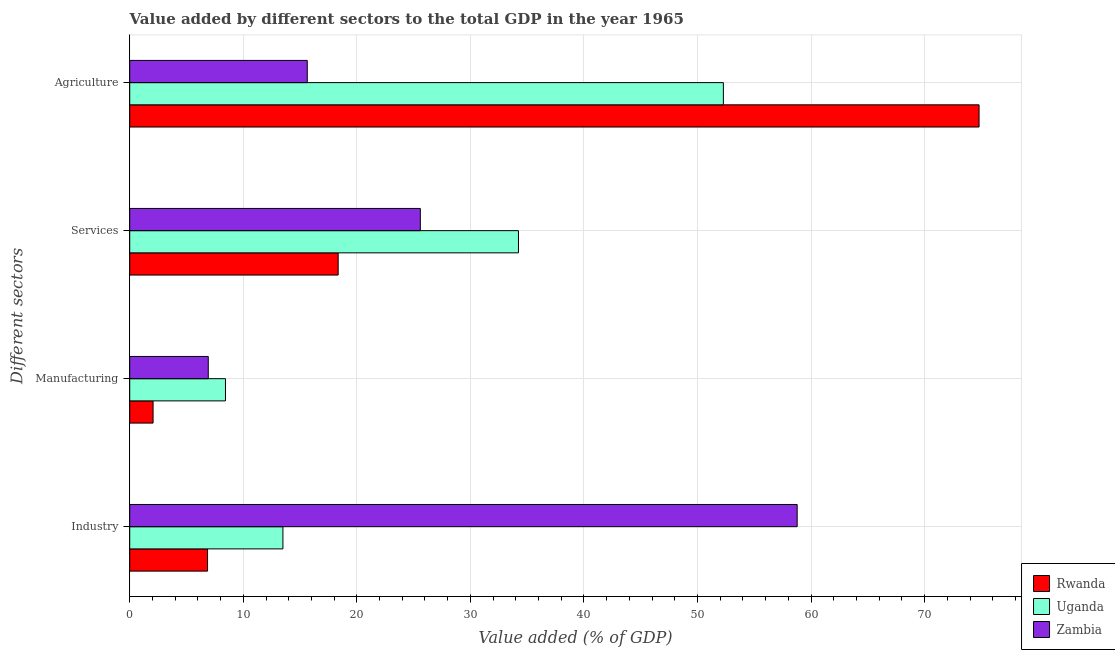How many different coloured bars are there?
Your answer should be compact. 3. How many groups of bars are there?
Give a very brief answer. 4. Are the number of bars per tick equal to the number of legend labels?
Your answer should be compact. Yes. How many bars are there on the 4th tick from the bottom?
Ensure brevity in your answer.  3. What is the label of the 2nd group of bars from the top?
Your answer should be compact. Services. What is the value added by agricultural sector in Uganda?
Make the answer very short. 52.28. Across all countries, what is the maximum value added by services sector?
Keep it short and to the point. 34.23. Across all countries, what is the minimum value added by manufacturing sector?
Your answer should be compact. 2.06. In which country was the value added by services sector maximum?
Your answer should be compact. Uganda. In which country was the value added by industrial sector minimum?
Your response must be concise. Rwanda. What is the total value added by agricultural sector in the graph?
Offer a very short reply. 142.7. What is the difference between the value added by industrial sector in Zambia and that in Rwanda?
Offer a very short reply. 51.92. What is the difference between the value added by services sector in Uganda and the value added by manufacturing sector in Rwanda?
Your response must be concise. 32.18. What is the average value added by agricultural sector per country?
Your answer should be very brief. 47.57. What is the difference between the value added by manufacturing sector and value added by services sector in Rwanda?
Give a very brief answer. -16.3. What is the ratio of the value added by services sector in Rwanda to that in Uganda?
Offer a very short reply. 0.54. Is the value added by agricultural sector in Uganda less than that in Zambia?
Your response must be concise. No. Is the difference between the value added by industrial sector in Zambia and Rwanda greater than the difference between the value added by manufacturing sector in Zambia and Rwanda?
Provide a short and direct response. Yes. What is the difference between the highest and the second highest value added by agricultural sector?
Your answer should be very brief. 22.52. What is the difference between the highest and the lowest value added by agricultural sector?
Provide a succinct answer. 59.16. What does the 3rd bar from the top in Services represents?
Give a very brief answer. Rwanda. What does the 3rd bar from the bottom in Manufacturing represents?
Offer a terse response. Zambia. What is the difference between two consecutive major ticks on the X-axis?
Your answer should be compact. 10. Does the graph contain any zero values?
Provide a succinct answer. No. How many legend labels are there?
Offer a terse response. 3. How are the legend labels stacked?
Your answer should be compact. Vertical. What is the title of the graph?
Your answer should be compact. Value added by different sectors to the total GDP in the year 1965. What is the label or title of the X-axis?
Ensure brevity in your answer.  Value added (% of GDP). What is the label or title of the Y-axis?
Ensure brevity in your answer.  Different sectors. What is the Value added (% of GDP) in Rwanda in Industry?
Your answer should be compact. 6.85. What is the Value added (% of GDP) of Uganda in Industry?
Offer a terse response. 13.49. What is the Value added (% of GDP) in Zambia in Industry?
Offer a terse response. 58.78. What is the Value added (% of GDP) in Rwanda in Manufacturing?
Offer a terse response. 2.06. What is the Value added (% of GDP) in Uganda in Manufacturing?
Your answer should be compact. 8.43. What is the Value added (% of GDP) of Zambia in Manufacturing?
Your answer should be compact. 6.92. What is the Value added (% of GDP) of Rwanda in Services?
Provide a short and direct response. 18.35. What is the Value added (% of GDP) in Uganda in Services?
Provide a short and direct response. 34.23. What is the Value added (% of GDP) of Zambia in Services?
Offer a terse response. 25.59. What is the Value added (% of GDP) in Rwanda in Agriculture?
Make the answer very short. 74.79. What is the Value added (% of GDP) of Uganda in Agriculture?
Make the answer very short. 52.28. What is the Value added (% of GDP) in Zambia in Agriculture?
Keep it short and to the point. 15.63. Across all Different sectors, what is the maximum Value added (% of GDP) in Rwanda?
Your response must be concise. 74.79. Across all Different sectors, what is the maximum Value added (% of GDP) of Uganda?
Give a very brief answer. 52.28. Across all Different sectors, what is the maximum Value added (% of GDP) of Zambia?
Your answer should be compact. 58.78. Across all Different sectors, what is the minimum Value added (% of GDP) of Rwanda?
Provide a succinct answer. 2.06. Across all Different sectors, what is the minimum Value added (% of GDP) in Uganda?
Ensure brevity in your answer.  8.43. Across all Different sectors, what is the minimum Value added (% of GDP) of Zambia?
Ensure brevity in your answer.  6.92. What is the total Value added (% of GDP) of Rwanda in the graph?
Your answer should be very brief. 102.06. What is the total Value added (% of GDP) of Uganda in the graph?
Ensure brevity in your answer.  108.43. What is the total Value added (% of GDP) in Zambia in the graph?
Offer a very short reply. 106.92. What is the difference between the Value added (% of GDP) of Rwanda in Industry and that in Manufacturing?
Your response must be concise. 4.8. What is the difference between the Value added (% of GDP) of Uganda in Industry and that in Manufacturing?
Your answer should be very brief. 5.06. What is the difference between the Value added (% of GDP) of Zambia in Industry and that in Manufacturing?
Your answer should be very brief. 51.86. What is the difference between the Value added (% of GDP) in Rwanda in Industry and that in Services?
Give a very brief answer. -11.5. What is the difference between the Value added (% of GDP) of Uganda in Industry and that in Services?
Your answer should be compact. -20.74. What is the difference between the Value added (% of GDP) in Zambia in Industry and that in Services?
Provide a short and direct response. 33.18. What is the difference between the Value added (% of GDP) in Rwanda in Industry and that in Agriculture?
Your answer should be compact. -67.94. What is the difference between the Value added (% of GDP) in Uganda in Industry and that in Agriculture?
Offer a very short reply. -38.79. What is the difference between the Value added (% of GDP) of Zambia in Industry and that in Agriculture?
Your answer should be compact. 43.14. What is the difference between the Value added (% of GDP) in Rwanda in Manufacturing and that in Services?
Offer a terse response. -16.3. What is the difference between the Value added (% of GDP) of Uganda in Manufacturing and that in Services?
Offer a terse response. -25.8. What is the difference between the Value added (% of GDP) of Zambia in Manufacturing and that in Services?
Your answer should be compact. -18.67. What is the difference between the Value added (% of GDP) in Rwanda in Manufacturing and that in Agriculture?
Offer a terse response. -72.74. What is the difference between the Value added (% of GDP) in Uganda in Manufacturing and that in Agriculture?
Your response must be concise. -43.84. What is the difference between the Value added (% of GDP) in Zambia in Manufacturing and that in Agriculture?
Give a very brief answer. -8.72. What is the difference between the Value added (% of GDP) in Rwanda in Services and that in Agriculture?
Ensure brevity in your answer.  -56.44. What is the difference between the Value added (% of GDP) in Uganda in Services and that in Agriculture?
Your answer should be very brief. -18.04. What is the difference between the Value added (% of GDP) of Zambia in Services and that in Agriculture?
Your response must be concise. 9.96. What is the difference between the Value added (% of GDP) of Rwanda in Industry and the Value added (% of GDP) of Uganda in Manufacturing?
Ensure brevity in your answer.  -1.58. What is the difference between the Value added (% of GDP) in Rwanda in Industry and the Value added (% of GDP) in Zambia in Manufacturing?
Your answer should be compact. -0.06. What is the difference between the Value added (% of GDP) in Uganda in Industry and the Value added (% of GDP) in Zambia in Manufacturing?
Give a very brief answer. 6.57. What is the difference between the Value added (% of GDP) of Rwanda in Industry and the Value added (% of GDP) of Uganda in Services?
Offer a terse response. -27.38. What is the difference between the Value added (% of GDP) of Rwanda in Industry and the Value added (% of GDP) of Zambia in Services?
Your response must be concise. -18.74. What is the difference between the Value added (% of GDP) in Uganda in Industry and the Value added (% of GDP) in Zambia in Services?
Give a very brief answer. -12.1. What is the difference between the Value added (% of GDP) of Rwanda in Industry and the Value added (% of GDP) of Uganda in Agriculture?
Your answer should be very brief. -45.42. What is the difference between the Value added (% of GDP) in Rwanda in Industry and the Value added (% of GDP) in Zambia in Agriculture?
Your response must be concise. -8.78. What is the difference between the Value added (% of GDP) of Uganda in Industry and the Value added (% of GDP) of Zambia in Agriculture?
Your answer should be very brief. -2.14. What is the difference between the Value added (% of GDP) of Rwanda in Manufacturing and the Value added (% of GDP) of Uganda in Services?
Provide a short and direct response. -32.18. What is the difference between the Value added (% of GDP) of Rwanda in Manufacturing and the Value added (% of GDP) of Zambia in Services?
Keep it short and to the point. -23.53. What is the difference between the Value added (% of GDP) in Uganda in Manufacturing and the Value added (% of GDP) in Zambia in Services?
Ensure brevity in your answer.  -17.16. What is the difference between the Value added (% of GDP) in Rwanda in Manufacturing and the Value added (% of GDP) in Uganda in Agriculture?
Offer a terse response. -50.22. What is the difference between the Value added (% of GDP) in Rwanda in Manufacturing and the Value added (% of GDP) in Zambia in Agriculture?
Give a very brief answer. -13.58. What is the difference between the Value added (% of GDP) of Uganda in Manufacturing and the Value added (% of GDP) of Zambia in Agriculture?
Your answer should be compact. -7.2. What is the difference between the Value added (% of GDP) of Rwanda in Services and the Value added (% of GDP) of Uganda in Agriculture?
Ensure brevity in your answer.  -33.92. What is the difference between the Value added (% of GDP) of Rwanda in Services and the Value added (% of GDP) of Zambia in Agriculture?
Your answer should be very brief. 2.72. What is the difference between the Value added (% of GDP) of Uganda in Services and the Value added (% of GDP) of Zambia in Agriculture?
Your answer should be compact. 18.6. What is the average Value added (% of GDP) in Rwanda per Different sectors?
Your response must be concise. 25.51. What is the average Value added (% of GDP) in Uganda per Different sectors?
Your answer should be compact. 27.11. What is the average Value added (% of GDP) in Zambia per Different sectors?
Your answer should be compact. 26.73. What is the difference between the Value added (% of GDP) of Rwanda and Value added (% of GDP) of Uganda in Industry?
Provide a succinct answer. -6.64. What is the difference between the Value added (% of GDP) of Rwanda and Value added (% of GDP) of Zambia in Industry?
Your answer should be very brief. -51.92. What is the difference between the Value added (% of GDP) of Uganda and Value added (% of GDP) of Zambia in Industry?
Your answer should be very brief. -45.28. What is the difference between the Value added (% of GDP) in Rwanda and Value added (% of GDP) in Uganda in Manufacturing?
Give a very brief answer. -6.38. What is the difference between the Value added (% of GDP) of Rwanda and Value added (% of GDP) of Zambia in Manufacturing?
Provide a succinct answer. -4.86. What is the difference between the Value added (% of GDP) in Uganda and Value added (% of GDP) in Zambia in Manufacturing?
Your answer should be compact. 1.52. What is the difference between the Value added (% of GDP) in Rwanda and Value added (% of GDP) in Uganda in Services?
Your response must be concise. -15.88. What is the difference between the Value added (% of GDP) in Rwanda and Value added (% of GDP) in Zambia in Services?
Provide a short and direct response. -7.24. What is the difference between the Value added (% of GDP) of Uganda and Value added (% of GDP) of Zambia in Services?
Offer a very short reply. 8.64. What is the difference between the Value added (% of GDP) of Rwanda and Value added (% of GDP) of Uganda in Agriculture?
Your answer should be compact. 22.52. What is the difference between the Value added (% of GDP) in Rwanda and Value added (% of GDP) in Zambia in Agriculture?
Provide a succinct answer. 59.16. What is the difference between the Value added (% of GDP) of Uganda and Value added (% of GDP) of Zambia in Agriculture?
Offer a terse response. 36.64. What is the ratio of the Value added (% of GDP) in Rwanda in Industry to that in Manufacturing?
Offer a terse response. 3.33. What is the ratio of the Value added (% of GDP) of Uganda in Industry to that in Manufacturing?
Your answer should be very brief. 1.6. What is the ratio of the Value added (% of GDP) in Zambia in Industry to that in Manufacturing?
Provide a short and direct response. 8.5. What is the ratio of the Value added (% of GDP) in Rwanda in Industry to that in Services?
Offer a terse response. 0.37. What is the ratio of the Value added (% of GDP) in Uganda in Industry to that in Services?
Keep it short and to the point. 0.39. What is the ratio of the Value added (% of GDP) of Zambia in Industry to that in Services?
Provide a short and direct response. 2.3. What is the ratio of the Value added (% of GDP) of Rwanda in Industry to that in Agriculture?
Provide a succinct answer. 0.09. What is the ratio of the Value added (% of GDP) of Uganda in Industry to that in Agriculture?
Make the answer very short. 0.26. What is the ratio of the Value added (% of GDP) in Zambia in Industry to that in Agriculture?
Your answer should be very brief. 3.76. What is the ratio of the Value added (% of GDP) of Rwanda in Manufacturing to that in Services?
Provide a succinct answer. 0.11. What is the ratio of the Value added (% of GDP) in Uganda in Manufacturing to that in Services?
Provide a succinct answer. 0.25. What is the ratio of the Value added (% of GDP) of Zambia in Manufacturing to that in Services?
Your answer should be compact. 0.27. What is the ratio of the Value added (% of GDP) of Rwanda in Manufacturing to that in Agriculture?
Your answer should be compact. 0.03. What is the ratio of the Value added (% of GDP) of Uganda in Manufacturing to that in Agriculture?
Make the answer very short. 0.16. What is the ratio of the Value added (% of GDP) in Zambia in Manufacturing to that in Agriculture?
Keep it short and to the point. 0.44. What is the ratio of the Value added (% of GDP) of Rwanda in Services to that in Agriculture?
Your response must be concise. 0.25. What is the ratio of the Value added (% of GDP) of Uganda in Services to that in Agriculture?
Provide a short and direct response. 0.65. What is the ratio of the Value added (% of GDP) in Zambia in Services to that in Agriculture?
Your answer should be very brief. 1.64. What is the difference between the highest and the second highest Value added (% of GDP) of Rwanda?
Give a very brief answer. 56.44. What is the difference between the highest and the second highest Value added (% of GDP) of Uganda?
Ensure brevity in your answer.  18.04. What is the difference between the highest and the second highest Value added (% of GDP) of Zambia?
Make the answer very short. 33.18. What is the difference between the highest and the lowest Value added (% of GDP) in Rwanda?
Give a very brief answer. 72.74. What is the difference between the highest and the lowest Value added (% of GDP) in Uganda?
Your answer should be very brief. 43.84. What is the difference between the highest and the lowest Value added (% of GDP) of Zambia?
Offer a terse response. 51.86. 